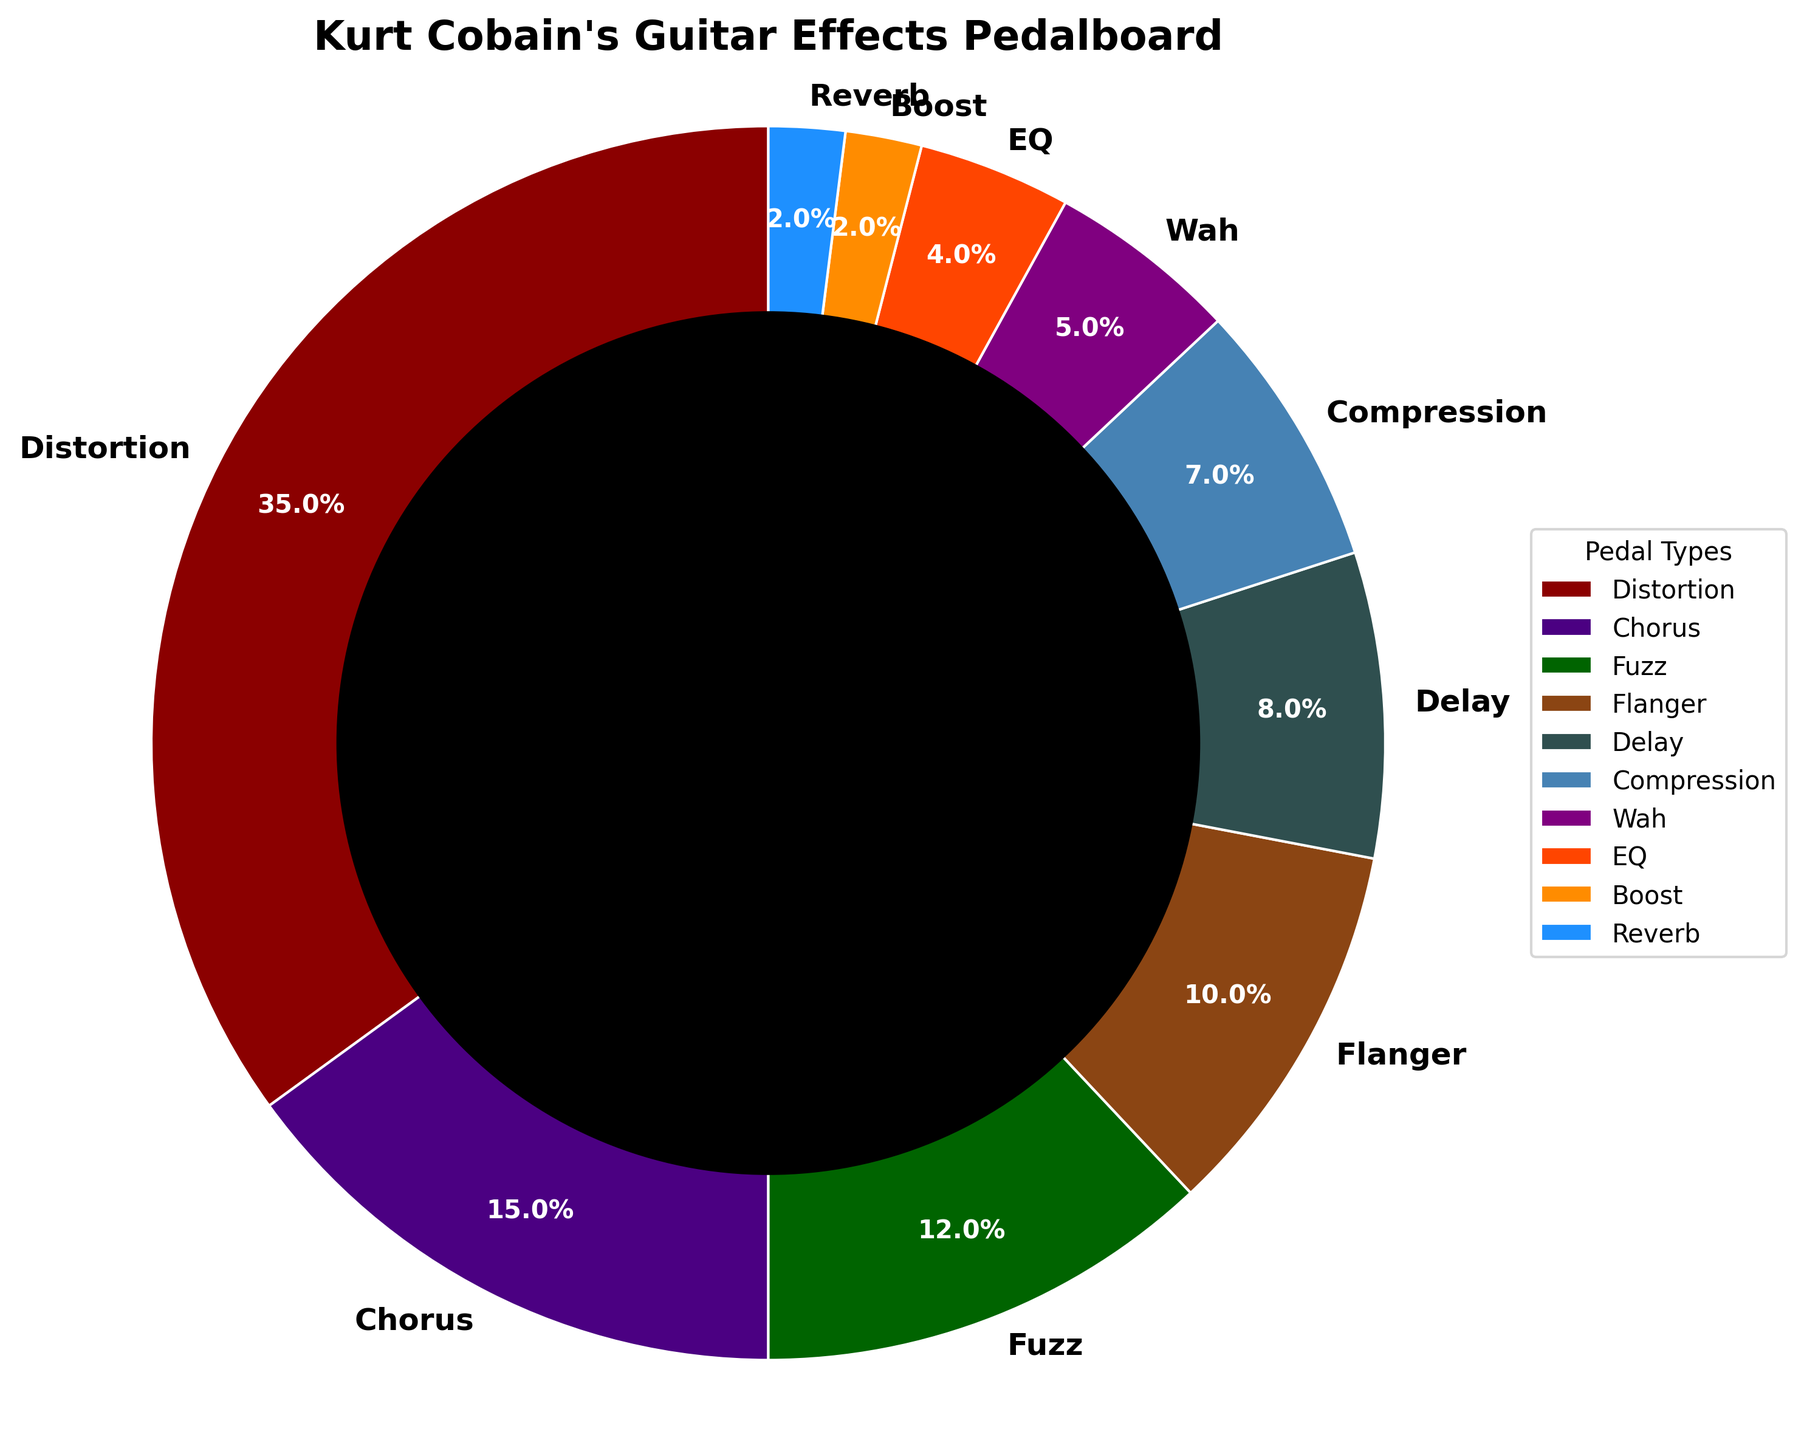Which pedal type has the highest percentage on Kurt Cobain's pedalboard? The figure shows different pedal types and their respective percentages. By visually comparing the segments, the Distortion pedal segment is the largest, with 35%.
Answer: Distortion What is the total percentage of the Distortion and Fuzz pedals combined? To find the combined percentage, simply add the percentages of Distortion and Fuzz. Distortion is 35% and Fuzz is 12%. Therefore, 35 + 12 = 47%.
Answer: 47% How much more is the percentage of Chorus pedals than EQ pedals? Identify the percentage for each pedal type: Chorus is 15%, and EQ is 4%. Calculate the difference: 15 - 4 = 11%.
Answer: 11% What is the combined percentage of Wah, EQ, Boost, and Reverb pedals? Add the percentages of these pedals: Wah (5%), EQ (4%), Boost (2%), Reverb (2%). Therefore, 5 + 4 + 2 + 2 = 13%.
Answer: 13% Are there more Delay or Chorus pedals on the pedalboard? Compare the segment sizes for Delay and Chorus. Delay is 8%, and Chorus is 15%. Thus, there are more Chorus pedals.
Answer: Chorus How does the percentage of the Flanger pedal compare to the Compression pedal? Look at both percentages: Flanger is 10%, and Compression is 7%. Flanger has a higher percentage.
Answer: Flanger Which pedal type occupies the smallest percentage? The figure shows percentages for each pedal type. Both Boost and Reverb are the smallest with 2% each.
Answer: Boost/Reverb If we combine the Chorus, Delay, and Flanger pedals, what percentage of the pedalboard do they constitute? Add the percentages of these pedals: Chorus (15%), Delay (8%), Flanger (10%). Therefore, 15 + 8 + 10 = 33%.
Answer: 33% What is the difference in percentage between the highest (Distortion) and the second-highest (Chorus) pedal types? Distortion is 35%, and Chorus is 15%. Therefore, 35 - 15 = 20%.
Answer: 20% What is the percentage of non-distortion pedals combined? Subtract the Distortion percentage from 100%: 100 - 35 = 65%.
Answer: 65% 